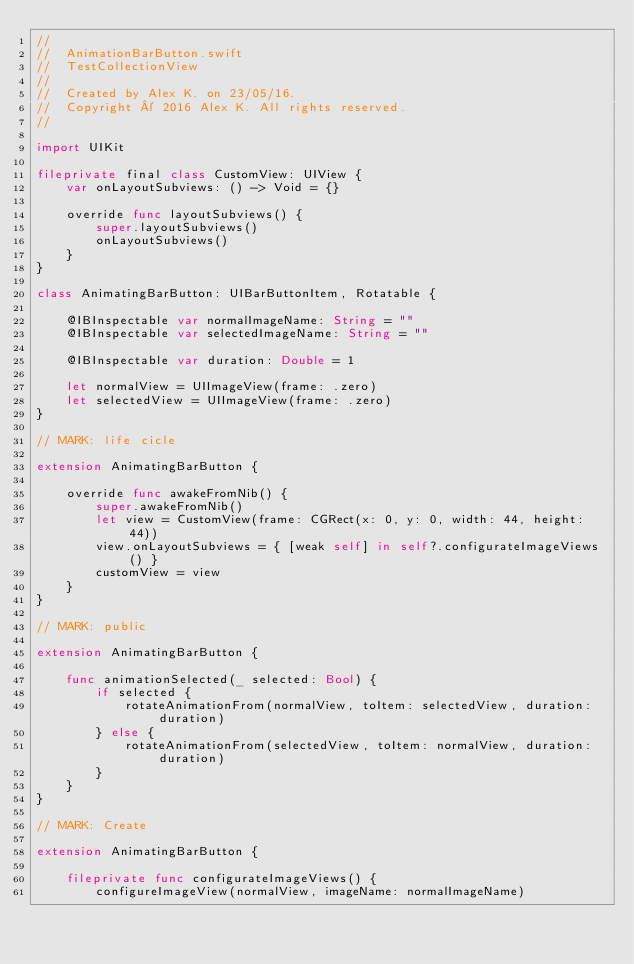Convert code to text. <code><loc_0><loc_0><loc_500><loc_500><_Swift_>//
//  AnimationBarButton.swift
//  TestCollectionView
//
//  Created by Alex K. on 23/05/16.
//  Copyright © 2016 Alex K. All rights reserved.
//

import UIKit

fileprivate final class CustomView: UIView {
    var onLayoutSubviews: () -> Void = {}

    override func layoutSubviews() {
        super.layoutSubviews()
        onLayoutSubviews()
    }
}

class AnimatingBarButton: UIBarButtonItem, Rotatable {

    @IBInspectable var normalImageName: String = ""
    @IBInspectable var selectedImageName: String = ""

    @IBInspectable var duration: Double = 1

    let normalView = UIImageView(frame: .zero)
    let selectedView = UIImageView(frame: .zero)
}

// MARK: life cicle

extension AnimatingBarButton {

    override func awakeFromNib() {
        super.awakeFromNib()
        let view = CustomView(frame: CGRect(x: 0, y: 0, width: 44, height: 44))
        view.onLayoutSubviews = { [weak self] in self?.configurateImageViews() }
        customView = view
    }
}

// MARK: public

extension AnimatingBarButton {

    func animationSelected(_ selected: Bool) {
        if selected {
            rotateAnimationFrom(normalView, toItem: selectedView, duration: duration)
        } else {
            rotateAnimationFrom(selectedView, toItem: normalView, duration: duration)
        }
    }
}

// MARK: Create

extension AnimatingBarButton {

    fileprivate func configurateImageViews() {
        configureImageView(normalView, imageName: normalImageName)</code> 